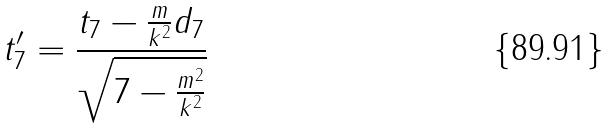<formula> <loc_0><loc_0><loc_500><loc_500>t _ { 7 } ^ { \prime } = \frac { t _ { 7 } - \frac { m } { k ^ { 2 } } d _ { 7 } } { \sqrt { 7 - \frac { m ^ { 2 } } { k ^ { 2 } } } }</formula> 